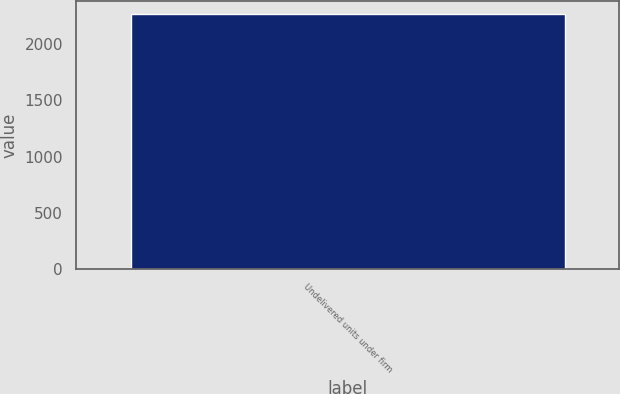Convert chart to OTSL. <chart><loc_0><loc_0><loc_500><loc_500><bar_chart><fcel>Undelivered units under firm<nl><fcel>2270<nl></chart> 